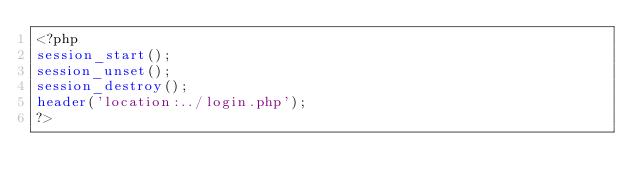Convert code to text. <code><loc_0><loc_0><loc_500><loc_500><_PHP_><?php
session_start();
session_unset();
session_destroy();
header('location:../login.php');
?></code> 